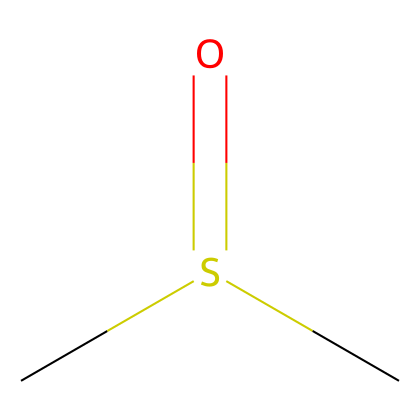How many carbon atoms are in the structure? The SMILES representation shows "C" before and after the "S(=O)", indicating two carbon atoms attached to the sulfur atom.
Answer: 2 What type of bond connects the carbon and sulfur in DMSO? In the SMILES "CS(=O)C", the connection between carbon and sulfur is a single bond, as indicated by the absence of any other bond symbols.
Answer: single How many oxygen atoms are present in the molecule? The "O" in the SMILES "S(=O)" indicates there are two oxygen atoms, one is involved in a double bond with sulfur and the other is implicit in the sulfoxide structure, recognized through the functional group.
Answer: 1 Which functional group does DMSO contain? Analyzing the structure, the presence of a sulfur atom bonded to an oxygen atom with a double bond signifies the sulfoxide functional group.
Answer: sulfoxide What is the hybridization of the carbon atoms in DMSO? The carbon atoms in DMSO are involved in sp3 hybridization, as they are single-bonded and tetrahedral based on the structure given in the SMILES.
Answer: sp3 What is the molecular formula of dimethyl sulfoxide? By counting the atoms represented in the SMILES "CS(=O)C", the total number of atoms gives the formula C2H6OS, accounting for the two carbons, six hydrogens, one oxygen, and one sulfur.
Answer: C2H6OS What role does DMSO play in electronics manufacturing? DMSO is utilized primarily as a solvent due to its ability to dissolve a variety of polar and nonpolar substances, making it valuable in the electronics industry for cleaning and processing.
Answer: solvent 